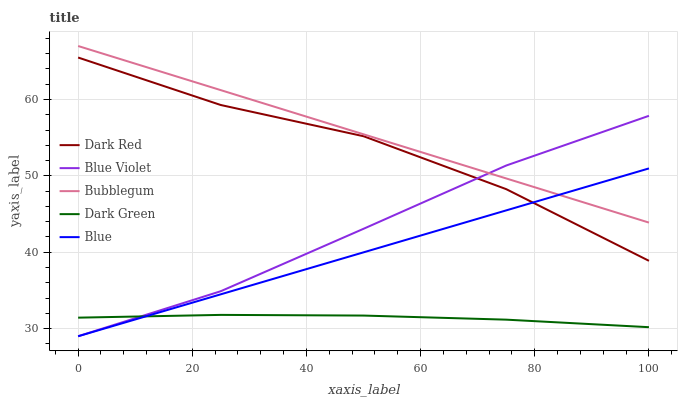Does Dark Green have the minimum area under the curve?
Answer yes or no. Yes. Does Bubblegum have the maximum area under the curve?
Answer yes or no. Yes. Does Dark Red have the minimum area under the curve?
Answer yes or no. No. Does Dark Red have the maximum area under the curve?
Answer yes or no. No. Is Blue the smoothest?
Answer yes or no. Yes. Is Dark Red the roughest?
Answer yes or no. Yes. Is Bubblegum the smoothest?
Answer yes or no. No. Is Bubblegum the roughest?
Answer yes or no. No. Does Blue have the lowest value?
Answer yes or no. Yes. Does Dark Red have the lowest value?
Answer yes or no. No. Does Bubblegum have the highest value?
Answer yes or no. Yes. Does Dark Red have the highest value?
Answer yes or no. No. Is Dark Green less than Dark Red?
Answer yes or no. Yes. Is Bubblegum greater than Dark Green?
Answer yes or no. Yes. Does Blue Violet intersect Dark Red?
Answer yes or no. Yes. Is Blue Violet less than Dark Red?
Answer yes or no. No. Is Blue Violet greater than Dark Red?
Answer yes or no. No. Does Dark Green intersect Dark Red?
Answer yes or no. No. 